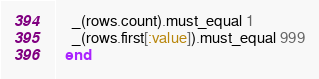<code> <loc_0><loc_0><loc_500><loc_500><_Ruby_>    _(rows.count).must_equal 1
    _(rows.first[:value]).must_equal 999
  end
</code> 